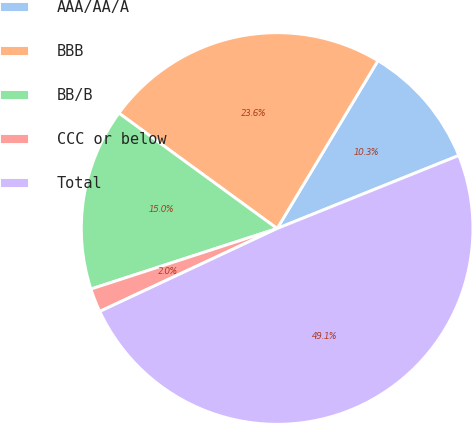Convert chart to OTSL. <chart><loc_0><loc_0><loc_500><loc_500><pie_chart><fcel>AAA/AA/A<fcel>BBB<fcel>BB/B<fcel>CCC or below<fcel>Total<nl><fcel>10.31%<fcel>23.58%<fcel>15.03%<fcel>1.96%<fcel>49.12%<nl></chart> 